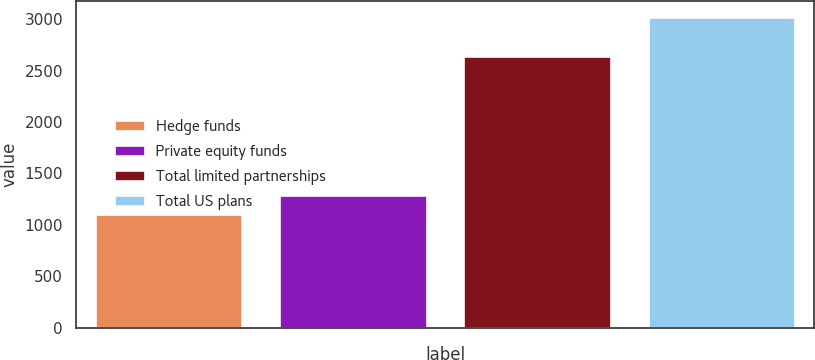<chart> <loc_0><loc_0><loc_500><loc_500><bar_chart><fcel>Hedge funds<fcel>Private equity funds<fcel>Total limited partnerships<fcel>Total US plans<nl><fcel>1102<fcel>1294.4<fcel>2638<fcel>3026<nl></chart> 